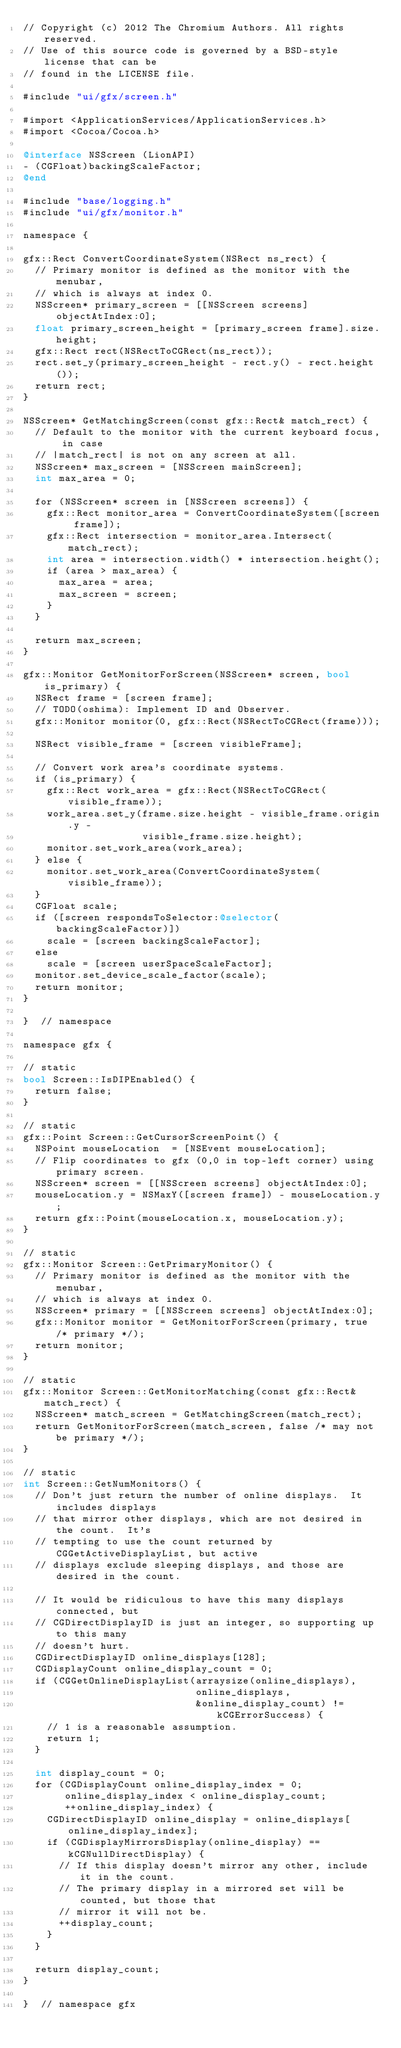Convert code to text. <code><loc_0><loc_0><loc_500><loc_500><_ObjectiveC_>// Copyright (c) 2012 The Chromium Authors. All rights reserved.
// Use of this source code is governed by a BSD-style license that can be
// found in the LICENSE file.

#include "ui/gfx/screen.h"

#import <ApplicationServices/ApplicationServices.h>
#import <Cocoa/Cocoa.h>

@interface NSScreen (LionAPI)
- (CGFloat)backingScaleFactor;
@end

#include "base/logging.h"
#include "ui/gfx/monitor.h"

namespace {

gfx::Rect ConvertCoordinateSystem(NSRect ns_rect) {
  // Primary monitor is defined as the monitor with the menubar,
  // which is always at index 0.
  NSScreen* primary_screen = [[NSScreen screens] objectAtIndex:0];
  float primary_screen_height = [primary_screen frame].size.height;
  gfx::Rect rect(NSRectToCGRect(ns_rect));
  rect.set_y(primary_screen_height - rect.y() - rect.height());
  return rect;
}

NSScreen* GetMatchingScreen(const gfx::Rect& match_rect) {
  // Default to the monitor with the current keyboard focus, in case
  // |match_rect| is not on any screen at all.
  NSScreen* max_screen = [NSScreen mainScreen];
  int max_area = 0;

  for (NSScreen* screen in [NSScreen screens]) {
    gfx::Rect monitor_area = ConvertCoordinateSystem([screen frame]);
    gfx::Rect intersection = monitor_area.Intersect(match_rect);
    int area = intersection.width() * intersection.height();
    if (area > max_area) {
      max_area = area;
      max_screen = screen;
    }
  }

  return max_screen;
}

gfx::Monitor GetMonitorForScreen(NSScreen* screen, bool is_primary) {
  NSRect frame = [screen frame];
  // TODO(oshima): Implement ID and Observer.
  gfx::Monitor monitor(0, gfx::Rect(NSRectToCGRect(frame)));

  NSRect visible_frame = [screen visibleFrame];

  // Convert work area's coordinate systems.
  if (is_primary) {
    gfx::Rect work_area = gfx::Rect(NSRectToCGRect(visible_frame));
    work_area.set_y(frame.size.height - visible_frame.origin.y -
                    visible_frame.size.height);
    monitor.set_work_area(work_area);
  } else {
    monitor.set_work_area(ConvertCoordinateSystem(visible_frame));
  }
  CGFloat scale;
  if ([screen respondsToSelector:@selector(backingScaleFactor)])
    scale = [screen backingScaleFactor];
  else
    scale = [screen userSpaceScaleFactor];
  monitor.set_device_scale_factor(scale);
  return monitor;
}

}  // namespace

namespace gfx {

// static
bool Screen::IsDIPEnabled() {
  return false;
}

// static
gfx::Point Screen::GetCursorScreenPoint() {
  NSPoint mouseLocation  = [NSEvent mouseLocation];
  // Flip coordinates to gfx (0,0 in top-left corner) using primary screen.
  NSScreen* screen = [[NSScreen screens] objectAtIndex:0];
  mouseLocation.y = NSMaxY([screen frame]) - mouseLocation.y;
  return gfx::Point(mouseLocation.x, mouseLocation.y);
}

// static
gfx::Monitor Screen::GetPrimaryMonitor() {
  // Primary monitor is defined as the monitor with the menubar,
  // which is always at index 0.
  NSScreen* primary = [[NSScreen screens] objectAtIndex:0];
  gfx::Monitor monitor = GetMonitorForScreen(primary, true /* primary */);
  return monitor;
}

// static
gfx::Monitor Screen::GetMonitorMatching(const gfx::Rect& match_rect) {
  NSScreen* match_screen = GetMatchingScreen(match_rect);
  return GetMonitorForScreen(match_screen, false /* may not be primary */);
}

// static
int Screen::GetNumMonitors() {
  // Don't just return the number of online displays.  It includes displays
  // that mirror other displays, which are not desired in the count.  It's
  // tempting to use the count returned by CGGetActiveDisplayList, but active
  // displays exclude sleeping displays, and those are desired in the count.

  // It would be ridiculous to have this many displays connected, but
  // CGDirectDisplayID is just an integer, so supporting up to this many
  // doesn't hurt.
  CGDirectDisplayID online_displays[128];
  CGDisplayCount online_display_count = 0;
  if (CGGetOnlineDisplayList(arraysize(online_displays),
                             online_displays,
                             &online_display_count) != kCGErrorSuccess) {
    // 1 is a reasonable assumption.
    return 1;
  }

  int display_count = 0;
  for (CGDisplayCount online_display_index = 0;
       online_display_index < online_display_count;
       ++online_display_index) {
    CGDirectDisplayID online_display = online_displays[online_display_index];
    if (CGDisplayMirrorsDisplay(online_display) == kCGNullDirectDisplay) {
      // If this display doesn't mirror any other, include it in the count.
      // The primary display in a mirrored set will be counted, but those that
      // mirror it will not be.
      ++display_count;
    }
  }

  return display_count;
}

}  // namespace gfx
</code> 